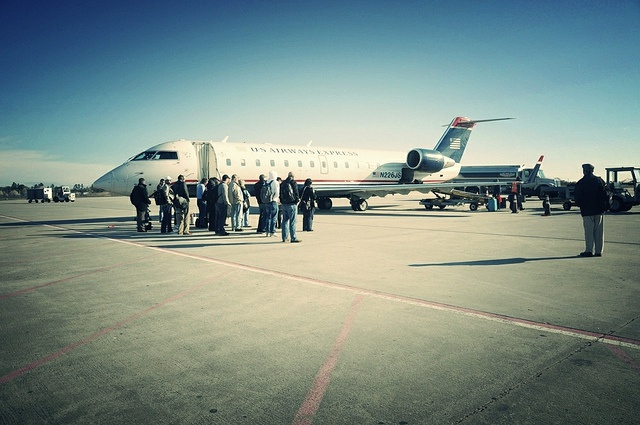Describe the objects in this image and their specific colors. I can see airplane in navy, beige, darkgray, teal, and black tones, people in navy, black, darkblue, gray, and purple tones, truck in navy, black, gray, darkgray, and beige tones, truck in navy, black, blue, teal, and gray tones, and people in navy, black, darkblue, blue, and gray tones in this image. 